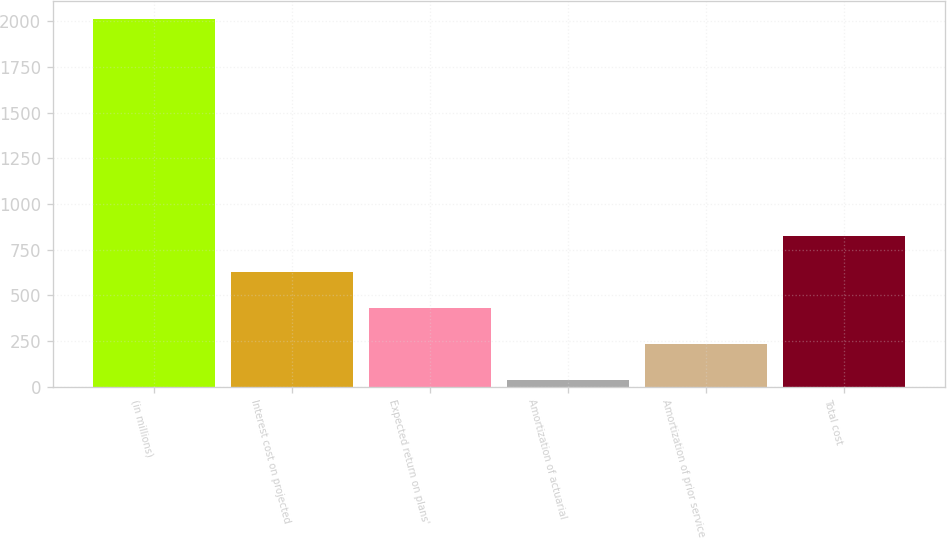Convert chart to OTSL. <chart><loc_0><loc_0><loc_500><loc_500><bar_chart><fcel>(in millions)<fcel>Interest cost on projected<fcel>Expected return on plans'<fcel>Amortization of actuarial<fcel>Amortization of prior service<fcel>Total cost<nl><fcel>2013<fcel>627.7<fcel>429.8<fcel>34<fcel>231.9<fcel>825.6<nl></chart> 